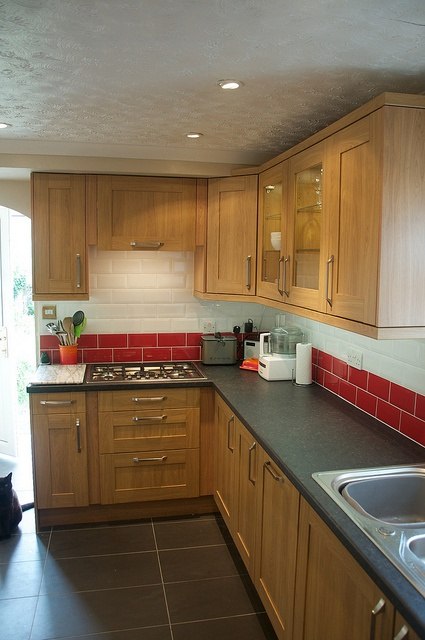Describe the objects in this image and their specific colors. I can see sink in gray, darkgray, and white tones, oven in gray, black, maroon, and tan tones, potted plant in gray, darkgray, and olive tones, cat in gray, black, and white tones, and sink in gray, darkgray, lightblue, and white tones in this image. 